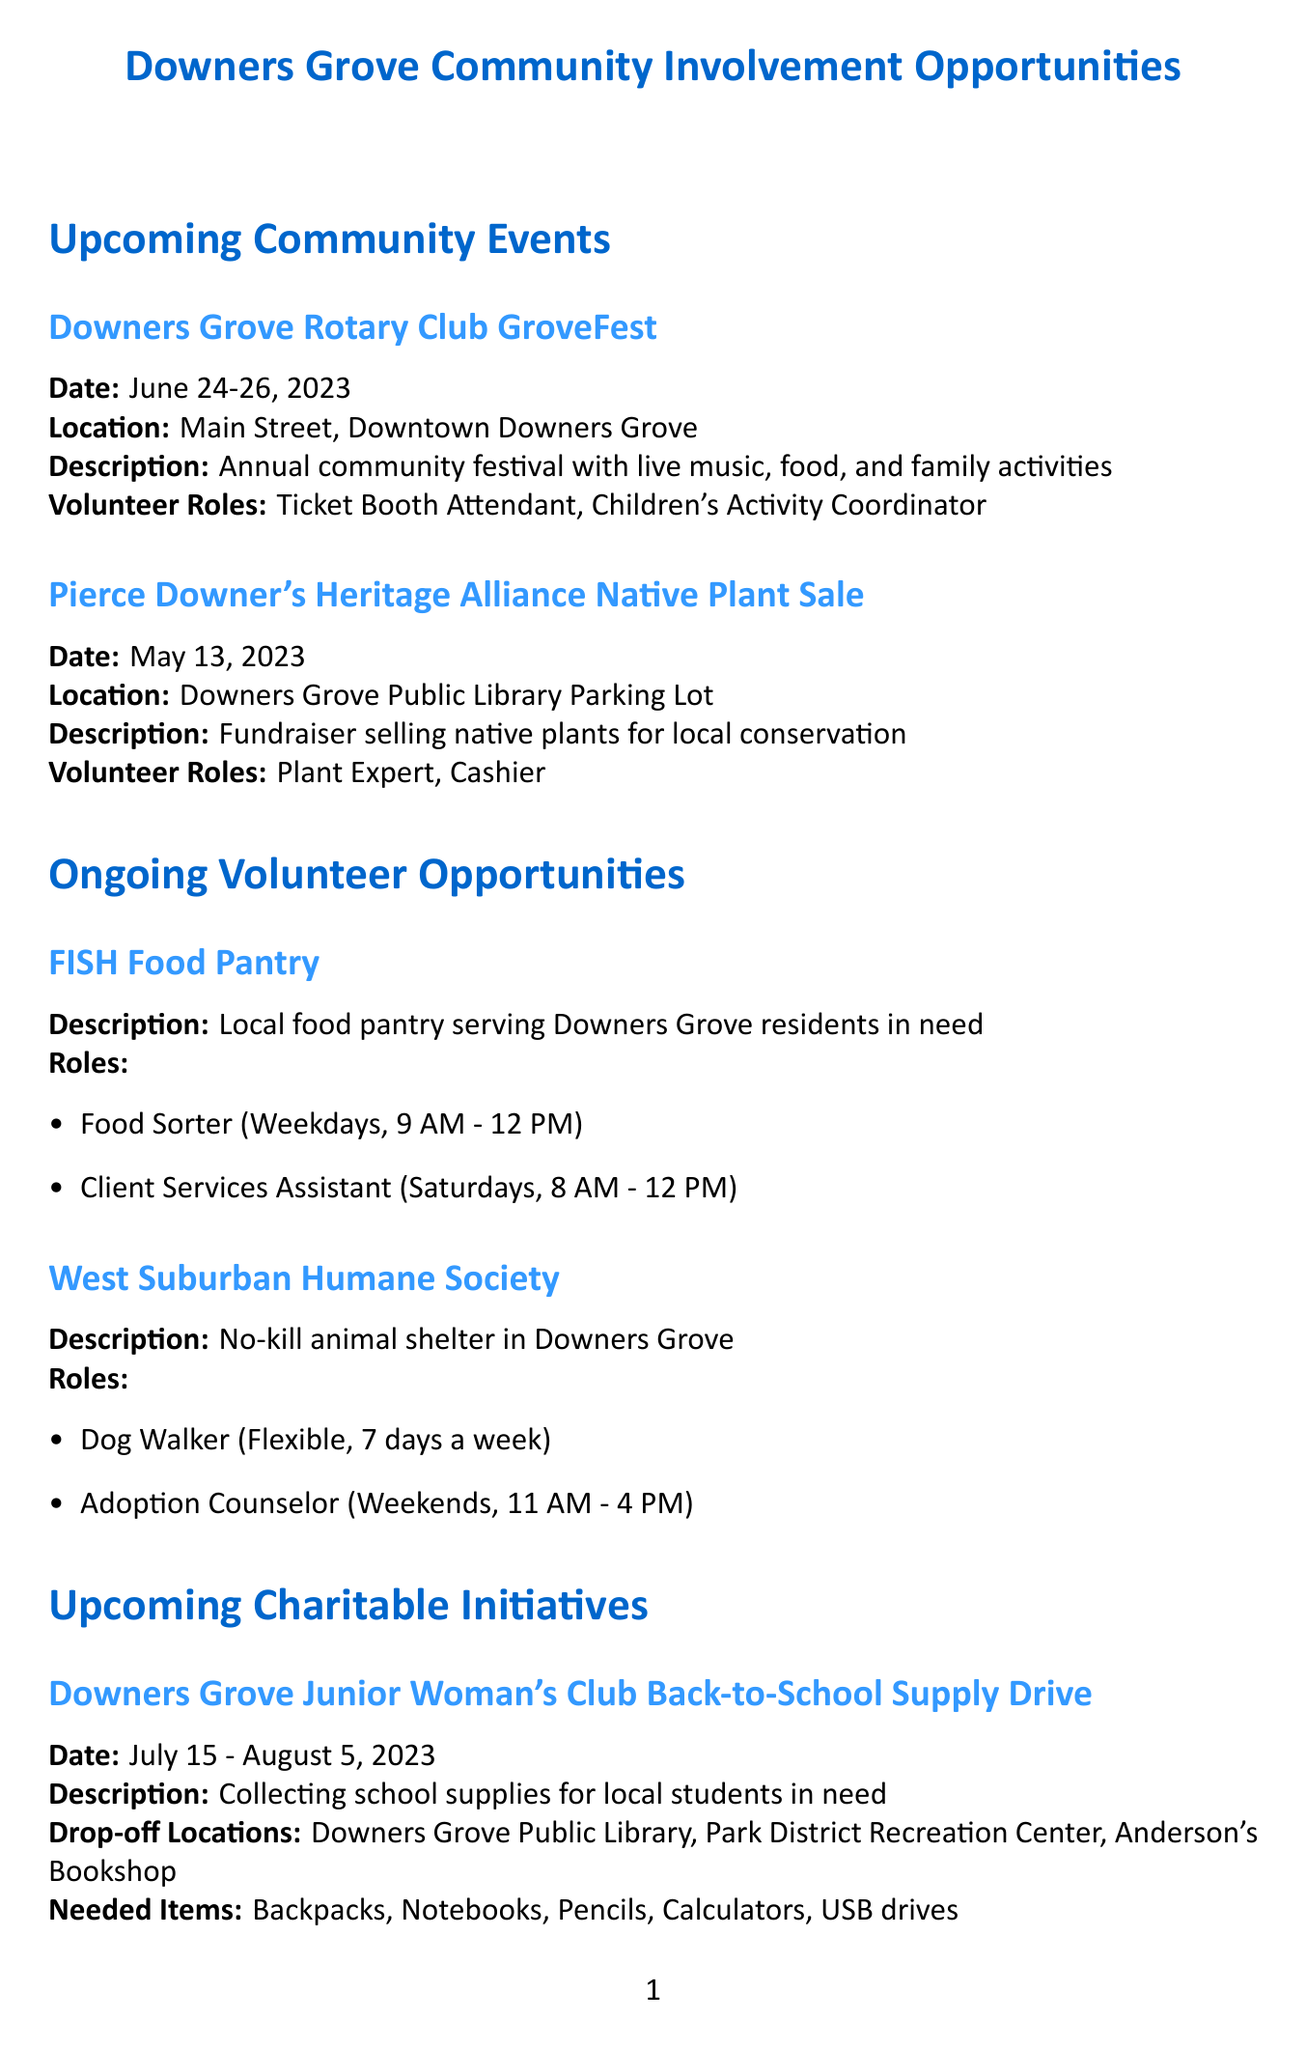What is the date of GroveFest? The date of GroveFest is mentioned in the document as June 24-26, 2023.
Answer: June 24-26, 2023 Where is the Native Plant Sale located? The location of the Native Plant Sale is specified in the document as the Downers Grove Public Library Parking Lot.
Answer: Downers Grove Public Library Parking Lot What skills are required for the Race Day Assistant role? The required skills for the Race Day Assistant role are stated as early morning availability and enthusiasm.
Answer: Early morning availability, enthusiasm What are the drop-off locations for the Back-to-School Supply Drive? The drop-off locations are listed in the document as Downers Grove Public Library, Park District Recreation Center, and Anderson's Bookshop.
Answer: Downers Grove Public Library, Park District Recreation Center, Anderson's Bookshop How many volunteer roles are available at the West Suburban Humane Society? The document specifies that there are two volunteer roles available at the West Suburban Humane Society: Dog Walker and Adoption Counselor.
Answer: Two What is the purpose of the Pierce Downer's Heritage Alliance Native Plant Sale? The purpose is described as a fundraiser selling native plants to support local conservation efforts.
Answer: Fundraiser for local conservation efforts What type of assistance is needed on Saturdays at FISH Food Pantry? The document indicates that a Client Services Assistant is needed on Saturdays at FISH Food Pantry.
Answer: Client Services Assistant What items are needed for the Back-to-School Supply Drive? The items needed include backpacks, notebooks, pencils, calculators, and USB drives as stated in the document.
Answer: Backpacks, notebooks, pencils, calculators, USB drives 